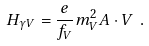<formula> <loc_0><loc_0><loc_500><loc_500>H _ { \gamma V } = \frac { e } { f _ { V } } m _ { V } ^ { 2 } { A \cdot V } \ .</formula> 